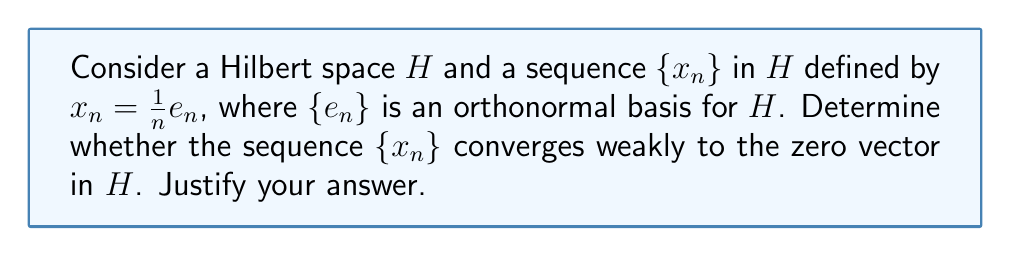Give your solution to this math problem. To investigate the weak convergence of the sequence $\{x_n\}$ to the zero vector in the Hilbert space $H$, we need to consider the following steps:

1) Recall that a sequence $\{x_n\}$ in a Hilbert space $H$ converges weakly to an element $x \in H$ if and only if $\langle x_n, y \rangle \to \langle x, y \rangle$ for all $y \in H$, where $\langle \cdot, \cdot \rangle$ denotes the inner product in $H$.

2) In this case, we want to check if $\langle x_n, y \rangle \to 0$ for all $y \in H$, since we're considering convergence to the zero vector.

3) Let $y$ be an arbitrary element in $H$. We can express $y$ in terms of the orthonormal basis $\{e_n\}$:

   $$y = \sum_{k=1}^{\infty} \langle y, e_k \rangle e_k$$

4) Now, let's consider the inner product $\langle x_n, y \rangle$:

   $$\langle x_n, y \rangle = \left\langle \frac{1}{n}e_n, \sum_{k=1}^{\infty} \langle y, e_k \rangle e_k \right\rangle$$

5) Using the linearity of the inner product and the orthonormality of $\{e_n\}$, we get:

   $$\langle x_n, y \rangle = \frac{1}{n} \langle y, e_n \rangle$$

6) As $n \to \infty$, we have:

   $$\lim_{n \to \infty} \langle x_n, y \rangle = \lim_{n \to \infty} \frac{1}{n} \langle y, e_n \rangle = 0$$

   This is because $\frac{1}{n} \to 0$ and $\langle y, e_n \rangle$ is bounded (by the Cauchy-Schwarz inequality).

7) Since this holds for any $y \in H$, we can conclude that $\{x_n\}$ converges weakly to the zero vector in $H$.
Answer: Yes, the sequence $\{x_n\}$ converges weakly to the zero vector in $H$. 